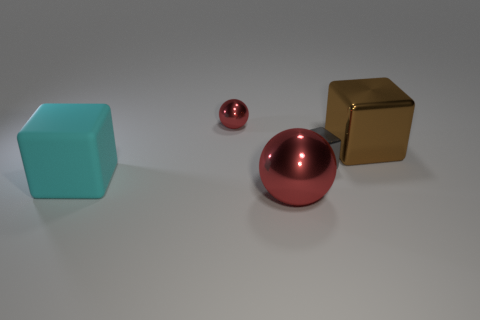Subtract all brown shiny blocks. How many blocks are left? 2 Add 2 tiny cyan cylinders. How many objects exist? 7 Subtract 2 balls. How many balls are left? 0 Subtract all brown blocks. How many blocks are left? 2 Subtract all gray spheres. How many red blocks are left? 0 Subtract all blocks. How many objects are left? 2 Subtract all cyan cubes. Subtract all cyan cylinders. How many cubes are left? 2 Subtract all purple rubber balls. Subtract all large brown metal objects. How many objects are left? 4 Add 1 cyan blocks. How many cyan blocks are left? 2 Add 4 big rubber things. How many big rubber things exist? 5 